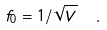Convert formula to latex. <formula><loc_0><loc_0><loc_500><loc_500>f _ { 0 } = 1 / \sqrt { V } \ \ .</formula> 